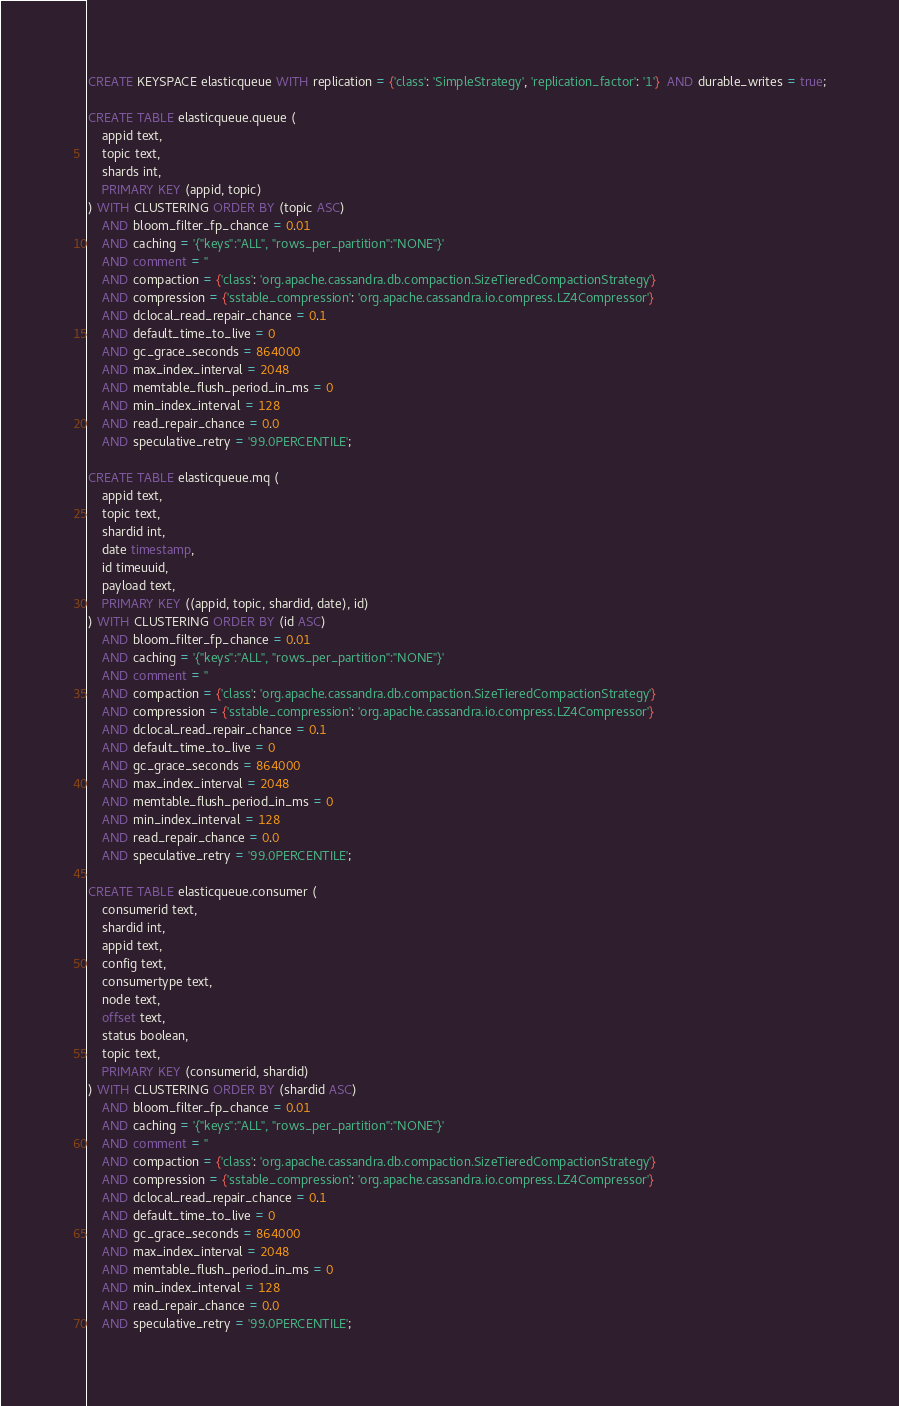<code> <loc_0><loc_0><loc_500><loc_500><_SQL_>CREATE KEYSPACE elasticqueue WITH replication = {'class': 'SimpleStrategy', 'replication_factor': '1'}  AND durable_writes = true;

CREATE TABLE elasticqueue.queue (
    appid text,
    topic text,
    shards int,
    PRIMARY KEY (appid, topic)
) WITH CLUSTERING ORDER BY (topic ASC)
    AND bloom_filter_fp_chance = 0.01
    AND caching = '{"keys":"ALL", "rows_per_partition":"NONE"}'
    AND comment = ''
    AND compaction = {'class': 'org.apache.cassandra.db.compaction.SizeTieredCompactionStrategy'}
    AND compression = {'sstable_compression': 'org.apache.cassandra.io.compress.LZ4Compressor'}
    AND dclocal_read_repair_chance = 0.1
    AND default_time_to_live = 0
    AND gc_grace_seconds = 864000
    AND max_index_interval = 2048
    AND memtable_flush_period_in_ms = 0
    AND min_index_interval = 128
    AND read_repair_chance = 0.0
    AND speculative_retry = '99.0PERCENTILE';

CREATE TABLE elasticqueue.mq (
    appid text,
    topic text,
    shardid int,
    date timestamp,
    id timeuuid,
    payload text,
    PRIMARY KEY ((appid, topic, shardid, date), id)
) WITH CLUSTERING ORDER BY (id ASC)
    AND bloom_filter_fp_chance = 0.01
    AND caching = '{"keys":"ALL", "rows_per_partition":"NONE"}'
    AND comment = ''
    AND compaction = {'class': 'org.apache.cassandra.db.compaction.SizeTieredCompactionStrategy'}
    AND compression = {'sstable_compression': 'org.apache.cassandra.io.compress.LZ4Compressor'}
    AND dclocal_read_repair_chance = 0.1
    AND default_time_to_live = 0
    AND gc_grace_seconds = 864000
    AND max_index_interval = 2048
    AND memtable_flush_period_in_ms = 0
    AND min_index_interval = 128
    AND read_repair_chance = 0.0
    AND speculative_retry = '99.0PERCENTILE';

CREATE TABLE elasticqueue.consumer (
    consumerid text,
    shardid int,
    appid text,
    config text,
    consumertype text,
    node text,
    offset text,
    status boolean,
    topic text,
    PRIMARY KEY (consumerid, shardid)
) WITH CLUSTERING ORDER BY (shardid ASC)
    AND bloom_filter_fp_chance = 0.01
    AND caching = '{"keys":"ALL", "rows_per_partition":"NONE"}'
    AND comment = ''
    AND compaction = {'class': 'org.apache.cassandra.db.compaction.SizeTieredCompactionStrategy'}
    AND compression = {'sstable_compression': 'org.apache.cassandra.io.compress.LZ4Compressor'}
    AND dclocal_read_repair_chance = 0.1
    AND default_time_to_live = 0
    AND gc_grace_seconds = 864000
    AND max_index_interval = 2048
    AND memtable_flush_period_in_ms = 0
    AND min_index_interval = 128
    AND read_repair_chance = 0.0
    AND speculative_retry = '99.0PERCENTILE';</code> 